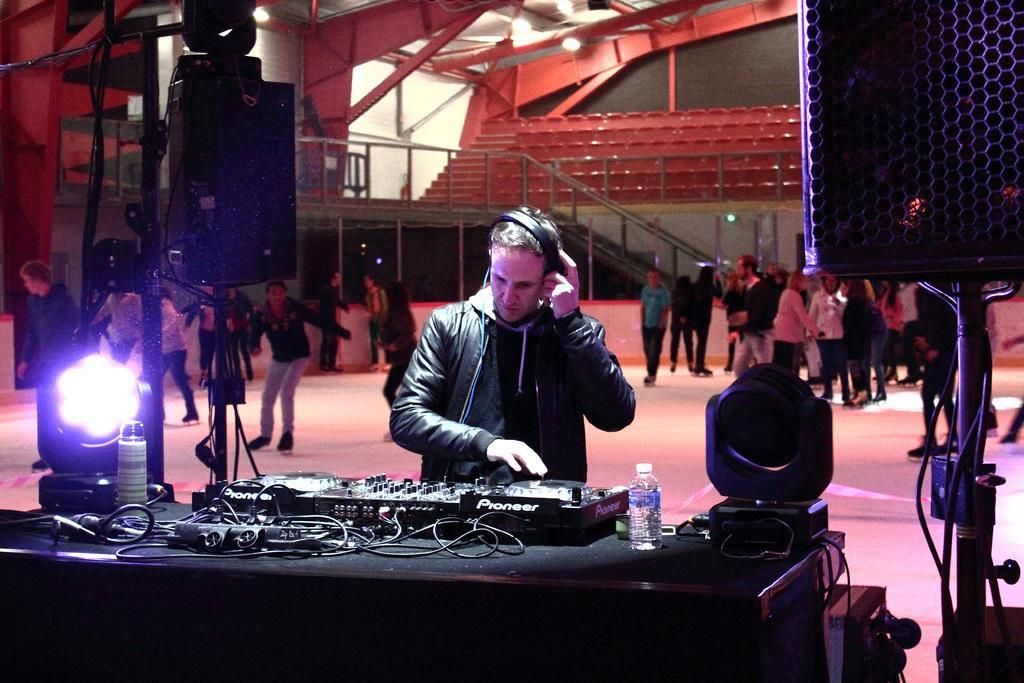Could you give a brief overview of what you see in this image? In this image in the front there is a table, on the table there are musical instruments. In the center there are persons standing and walking. In the background there are steps, there are empty seats and there are windows and at the top there are lights, there are poles, there is a railing and there is a stand which is visible. 